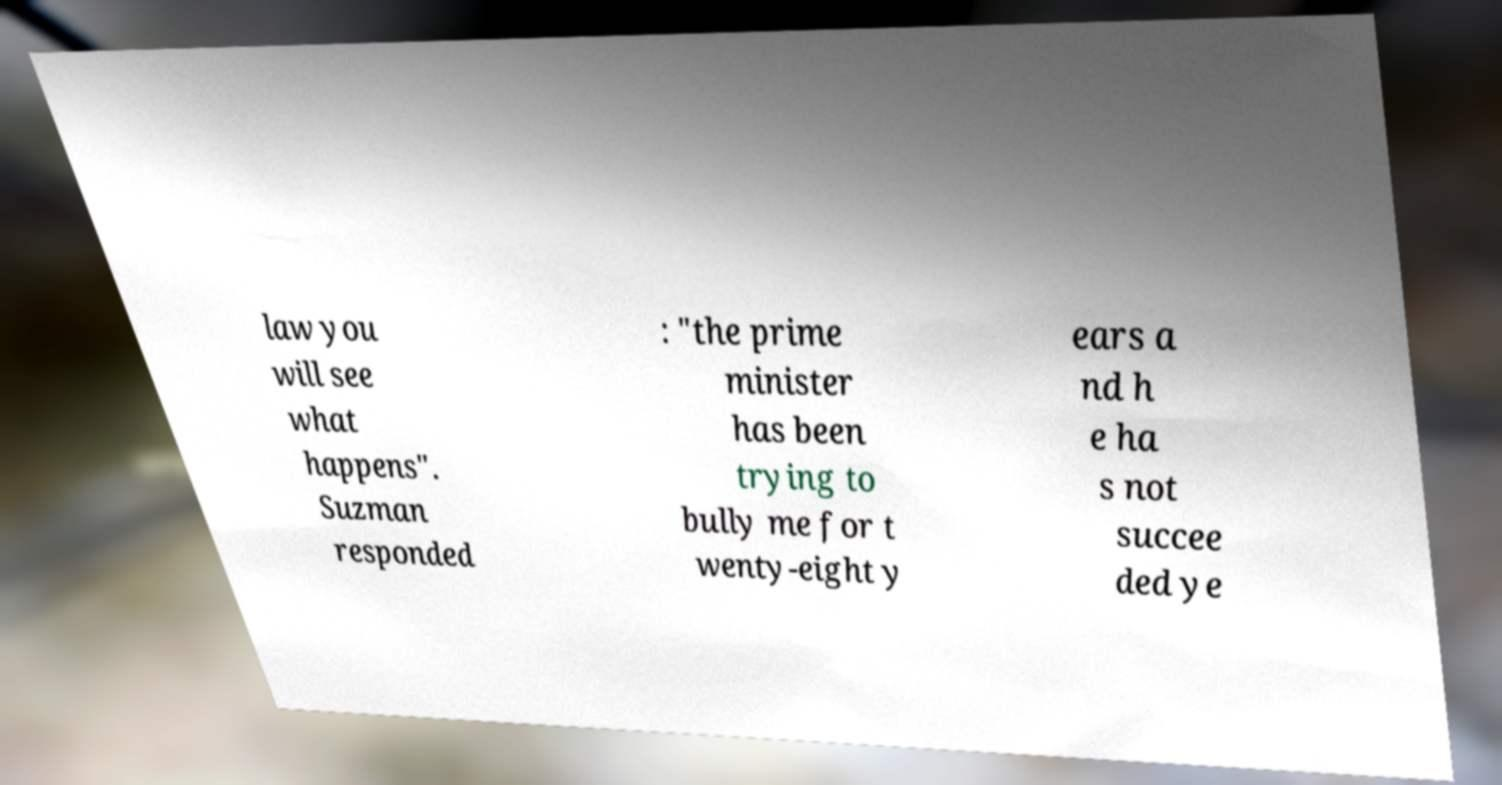Can you read and provide the text displayed in the image?This photo seems to have some interesting text. Can you extract and type it out for me? law you will see what happens". Suzman responded : "the prime minister has been trying to bully me for t wenty-eight y ears a nd h e ha s not succee ded ye 